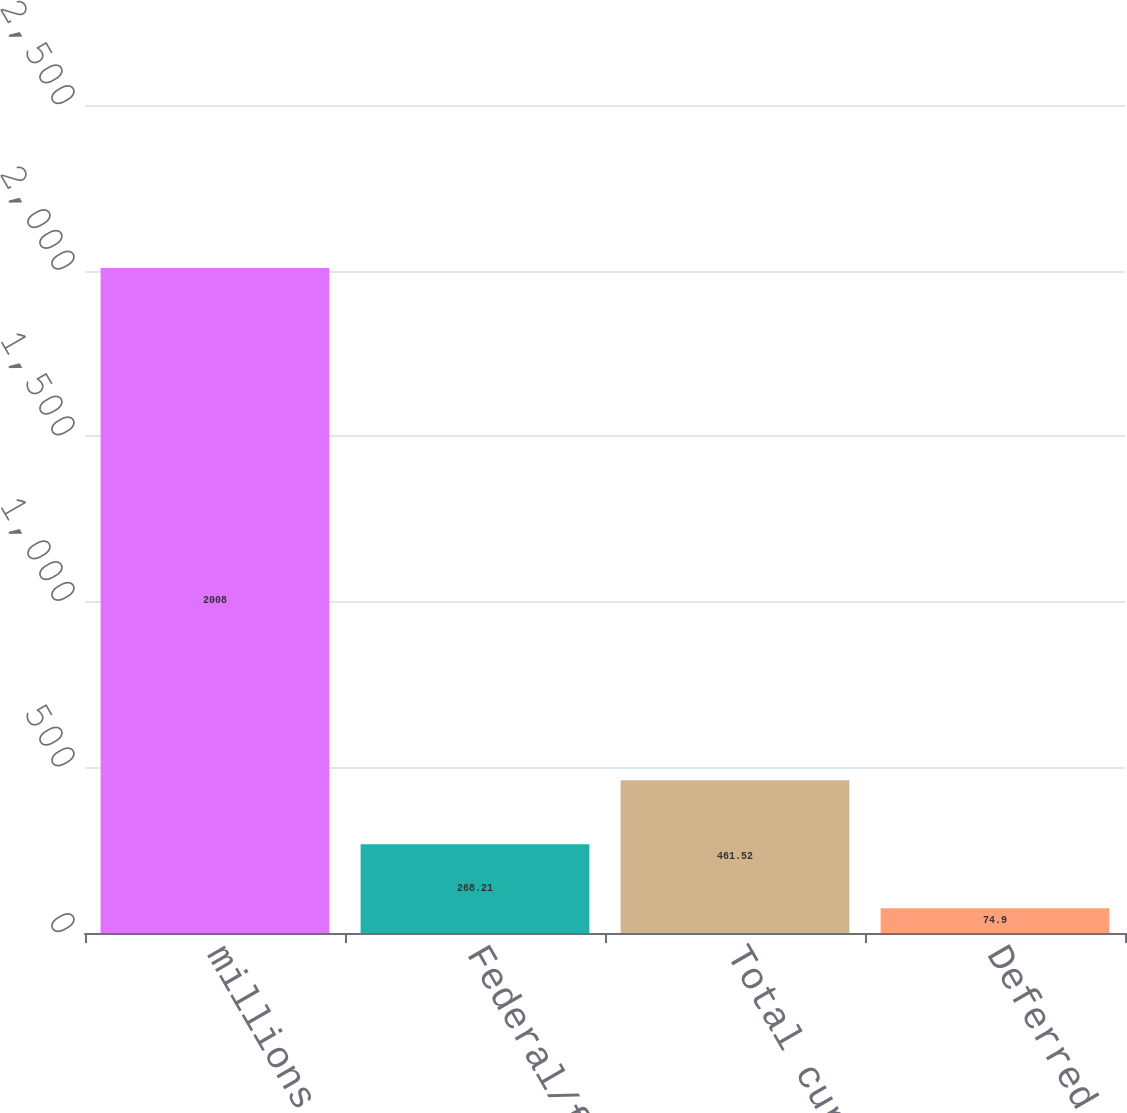Convert chart to OTSL. <chart><loc_0><loc_0><loc_500><loc_500><bar_chart><fcel>millions of Dollars<fcel>Federal/foreign<fcel>Total current<fcel>Deferred<nl><fcel>2008<fcel>268.21<fcel>461.52<fcel>74.9<nl></chart> 